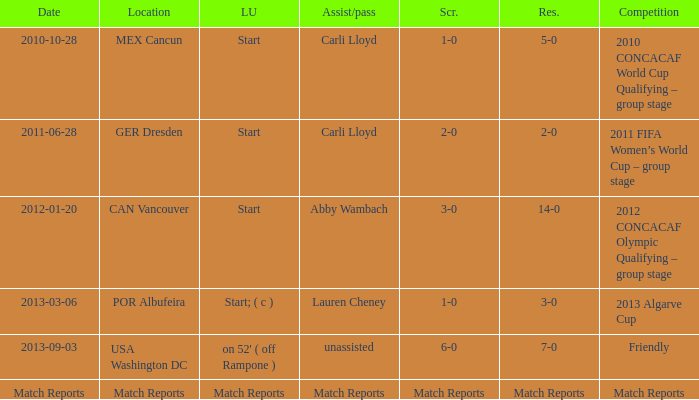Name the Result of the Lineup of start, an Assist/pass of carli lloyd, and an Competition of 2011 fifa women’s world cup – group stage? 2-0. 